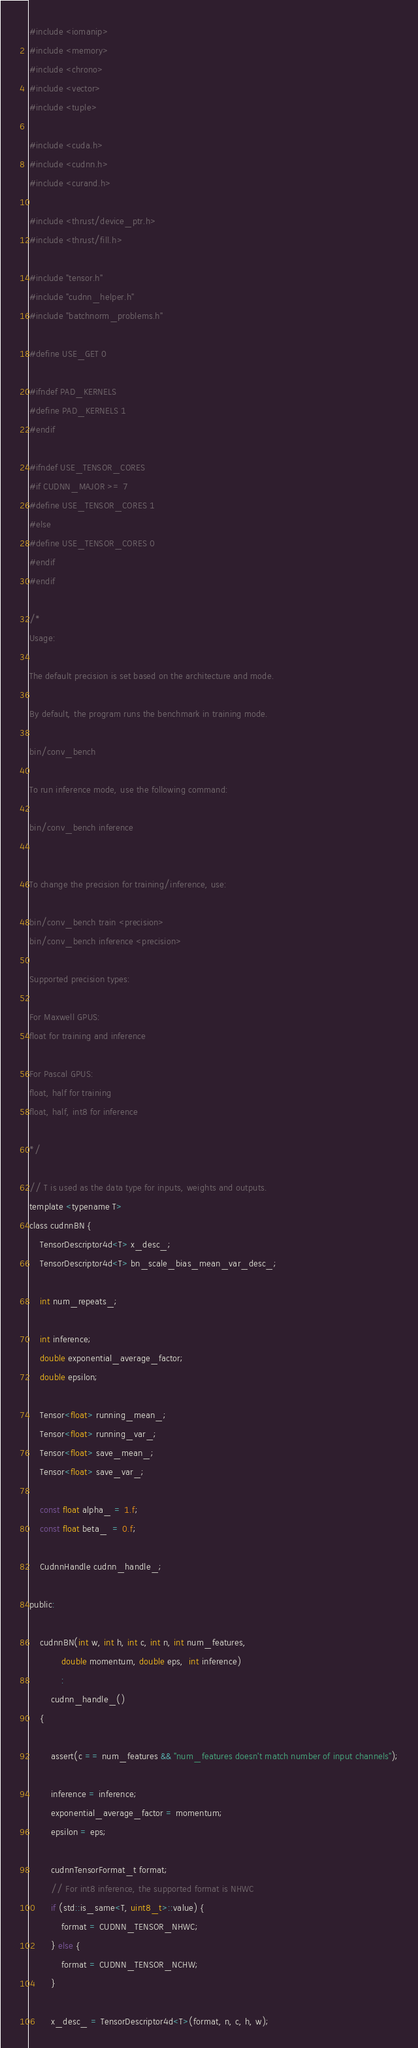<code> <loc_0><loc_0><loc_500><loc_500><_Cuda_>#include <iomanip>
#include <memory>
#include <chrono>
#include <vector>
#include <tuple>

#include <cuda.h>
#include <cudnn.h>
#include <curand.h>

#include <thrust/device_ptr.h>
#include <thrust/fill.h>

#include "tensor.h"
#include "cudnn_helper.h"
#include "batchnorm_problems.h"

#define USE_GET 0

#ifndef PAD_KERNELS
#define PAD_KERNELS 1
#endif

#ifndef USE_TENSOR_CORES
#if CUDNN_MAJOR >= 7
#define USE_TENSOR_CORES 1
#else
#define USE_TENSOR_CORES 0
#endif
#endif

/*
Usage:

The default precision is set based on the architecture and mode.

By default, the program runs the benchmark in training mode.

bin/conv_bench

To run inference mode, use the following command:

bin/conv_bench inference


To change the precision for training/inference, use:

bin/conv_bench train <precision>
bin/conv_bench inference <precision>

Supported precision types:

For Maxwell GPUS: 
float for training and inference

For Pascal GPUS:
float, half for training
float, half, int8 for inference

*/

// T is used as the data type for inputs, weights and outputs. 
template <typename T>
class cudnnBN {
    TensorDescriptor4d<T> x_desc_;
    TensorDescriptor4d<T> bn_scale_bias_mean_var_desc_;

    int num_repeats_;

    int inference;
    double exponential_average_factor;
    double epsilon;

    Tensor<float> running_mean_;
    Tensor<float> running_var_;
    Tensor<float> save_mean_;
    Tensor<float> save_var_;

    const float alpha_ = 1.f;
    const float beta_  = 0.f;

    CudnnHandle cudnn_handle_;

public:

    cudnnBN(int w, int h, int c, int n, int num_features,
            double momentum, double eps,  int inference)
            :
        cudnn_handle_()
    {

        assert(c == num_features && "num_features doesn't match number of input channels");
        
        inference = inference;
        exponential_average_factor = momentum;
        epsilon = eps;

        cudnnTensorFormat_t format;
        // For int8 inference, the supported format is NHWC
        if (std::is_same<T, uint8_t>::value) {
            format = CUDNN_TENSOR_NHWC;
        } else {
            format = CUDNN_TENSOR_NCHW;
        }

        x_desc_ = TensorDescriptor4d<T>(format, n, c, h, w);</code> 